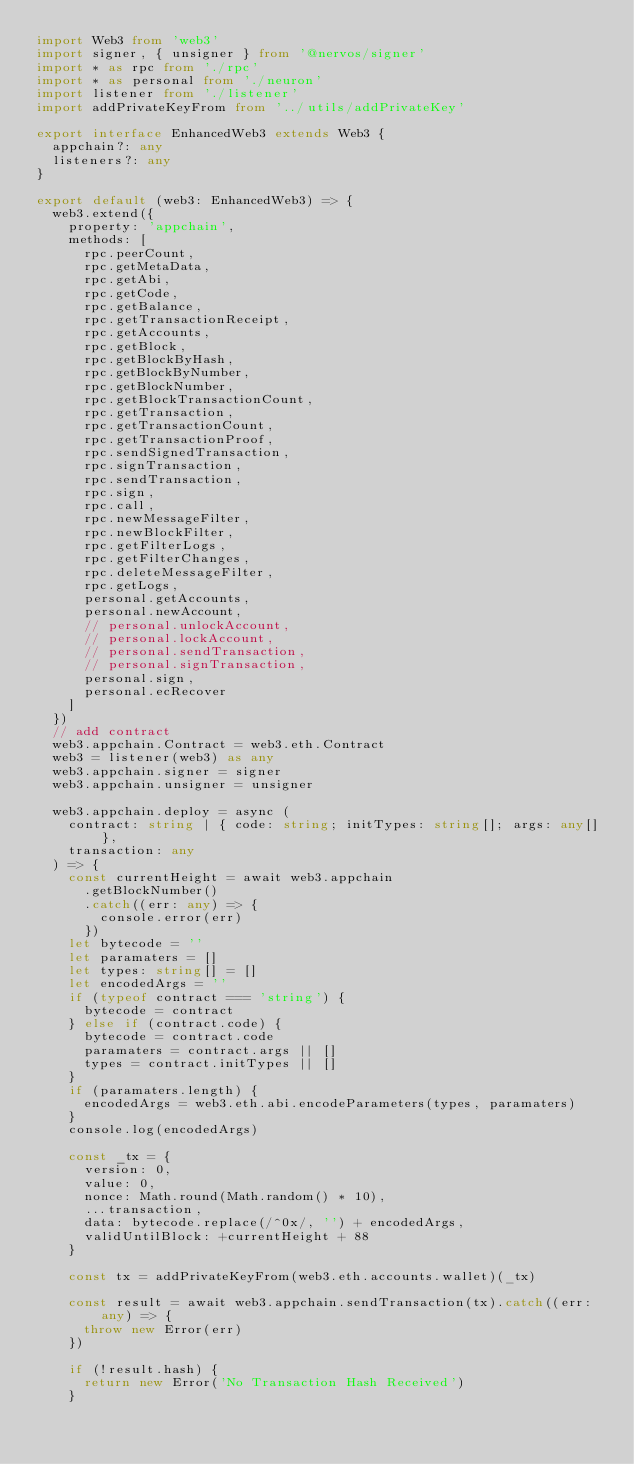<code> <loc_0><loc_0><loc_500><loc_500><_TypeScript_>import Web3 from 'web3'
import signer, { unsigner } from '@nervos/signer'
import * as rpc from './rpc'
import * as personal from './neuron'
import listener from './listener'
import addPrivateKeyFrom from '../utils/addPrivateKey'

export interface EnhancedWeb3 extends Web3 {
  appchain?: any
  listeners?: any
}

export default (web3: EnhancedWeb3) => {
  web3.extend({
    property: 'appchain',
    methods: [
      rpc.peerCount,
      rpc.getMetaData,
      rpc.getAbi,
      rpc.getCode,
      rpc.getBalance,
      rpc.getTransactionReceipt,
      rpc.getAccounts,
      rpc.getBlock,
      rpc.getBlockByHash,
      rpc.getBlockByNumber,
      rpc.getBlockNumber,
      rpc.getBlockTransactionCount,
      rpc.getTransaction,
      rpc.getTransactionCount,
      rpc.getTransactionProof,
      rpc.sendSignedTransaction,
      rpc.signTransaction,
      rpc.sendTransaction,
      rpc.sign,
      rpc.call,
      rpc.newMessageFilter,
      rpc.newBlockFilter,
      rpc.getFilterLogs,
      rpc.getFilterChanges,
      rpc.deleteMessageFilter,
      rpc.getLogs,
      personal.getAccounts,
      personal.newAccount,
      // personal.unlockAccount,
      // personal.lockAccount,
      // personal.sendTransaction,
      // personal.signTransaction,
      personal.sign,
      personal.ecRecover
    ]
  })
  // add contract
  web3.appchain.Contract = web3.eth.Contract
  web3 = listener(web3) as any
  web3.appchain.signer = signer
  web3.appchain.unsigner = unsigner

  web3.appchain.deploy = async (
    contract: string | { code: string; initTypes: string[]; args: any[] },
    transaction: any
  ) => {
    const currentHeight = await web3.appchain
      .getBlockNumber()
      .catch((err: any) => {
        console.error(err)
      })
    let bytecode = ''
    let paramaters = []
    let types: string[] = []
    let encodedArgs = ''
    if (typeof contract === 'string') {
      bytecode = contract
    } else if (contract.code) {
      bytecode = contract.code
      paramaters = contract.args || []
      types = contract.initTypes || []
    }
    if (paramaters.length) {
      encodedArgs = web3.eth.abi.encodeParameters(types, paramaters)
    }
    console.log(encodedArgs)

    const _tx = {
      version: 0,
      value: 0,
      nonce: Math.round(Math.random() * 10),
      ...transaction,
      data: bytecode.replace(/^0x/, '') + encodedArgs,
      validUntilBlock: +currentHeight + 88
    }

    const tx = addPrivateKeyFrom(web3.eth.accounts.wallet)(_tx)

    const result = await web3.appchain.sendTransaction(tx).catch((err: any) => {
      throw new Error(err)
    })

    if (!result.hash) {
      return new Error('No Transaction Hash Received')
    }</code> 